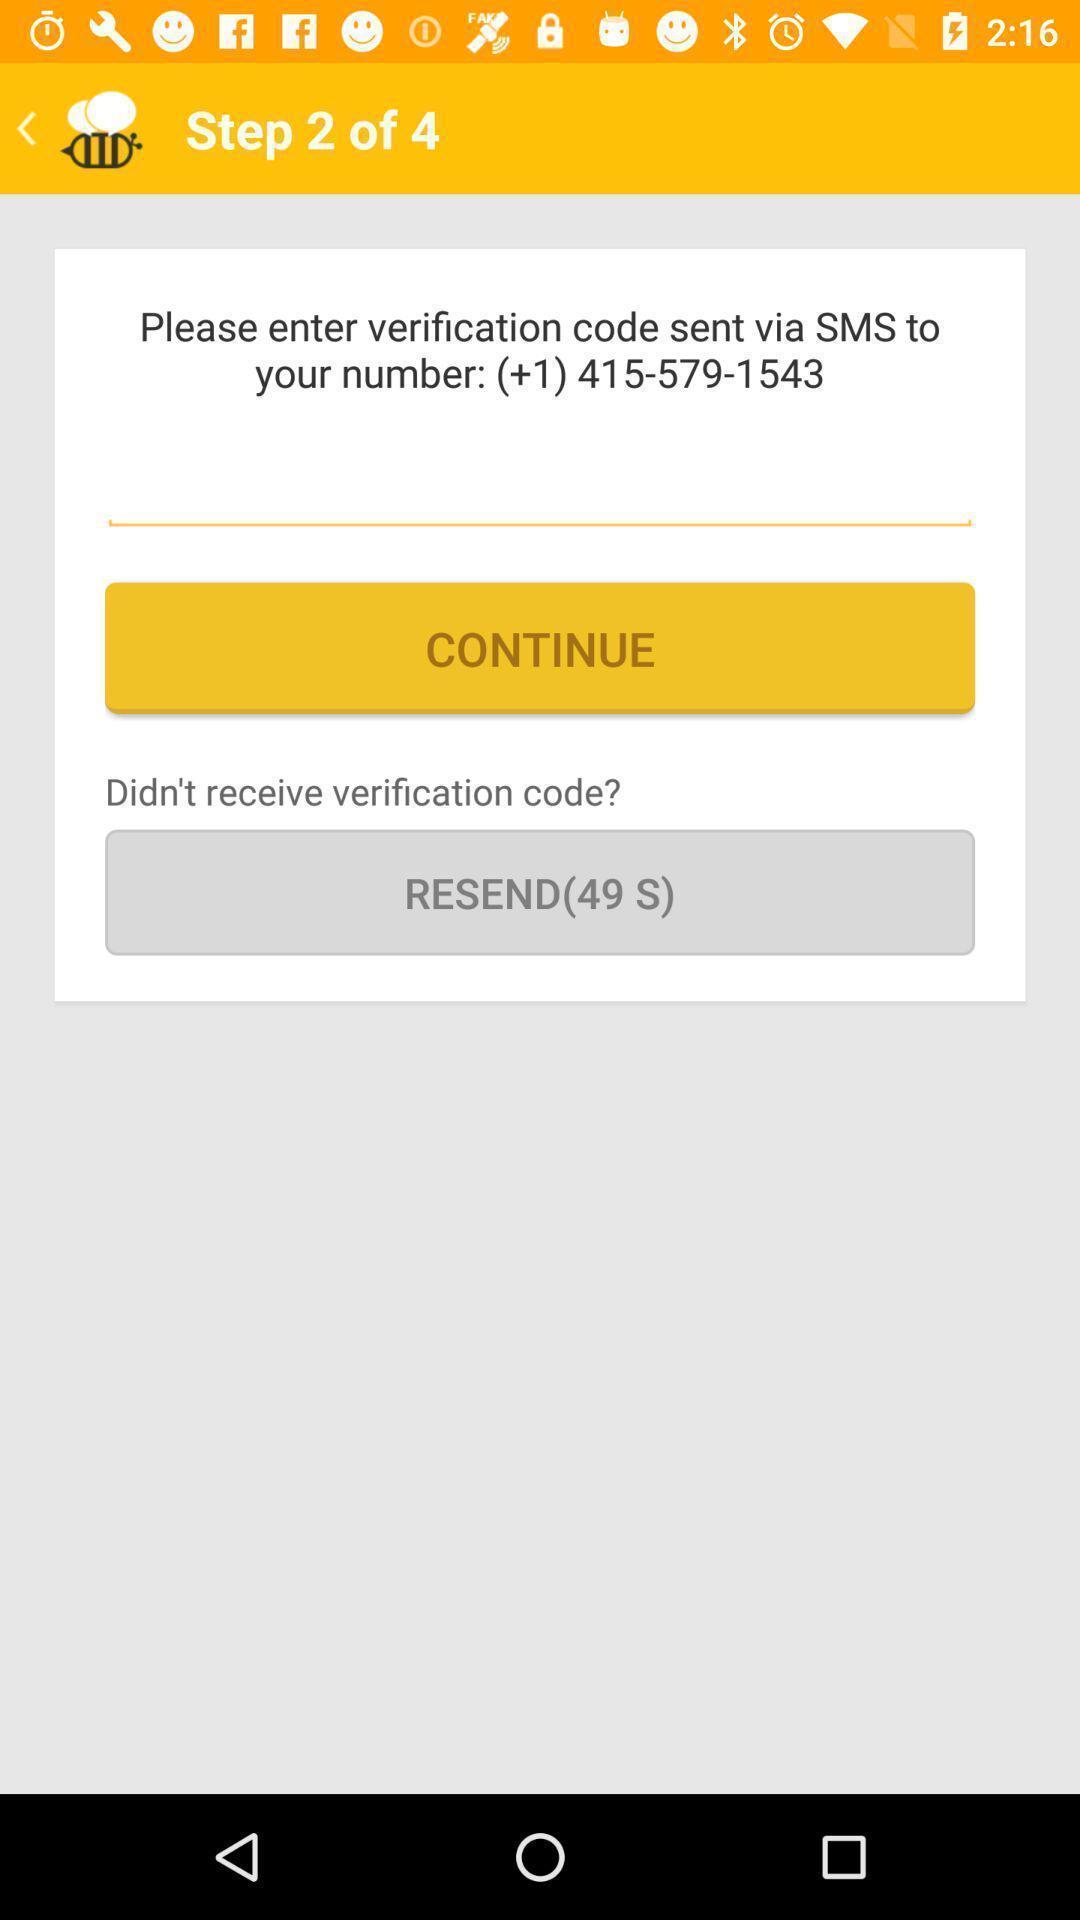Describe the visual elements of this screenshot. Screen showing to enter verification code option. 